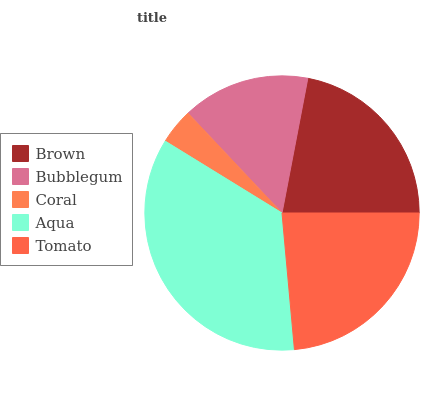Is Coral the minimum?
Answer yes or no. Yes. Is Aqua the maximum?
Answer yes or no. Yes. Is Bubblegum the minimum?
Answer yes or no. No. Is Bubblegum the maximum?
Answer yes or no. No. Is Brown greater than Bubblegum?
Answer yes or no. Yes. Is Bubblegum less than Brown?
Answer yes or no. Yes. Is Bubblegum greater than Brown?
Answer yes or no. No. Is Brown less than Bubblegum?
Answer yes or no. No. Is Brown the high median?
Answer yes or no. Yes. Is Brown the low median?
Answer yes or no. Yes. Is Bubblegum the high median?
Answer yes or no. No. Is Coral the low median?
Answer yes or no. No. 